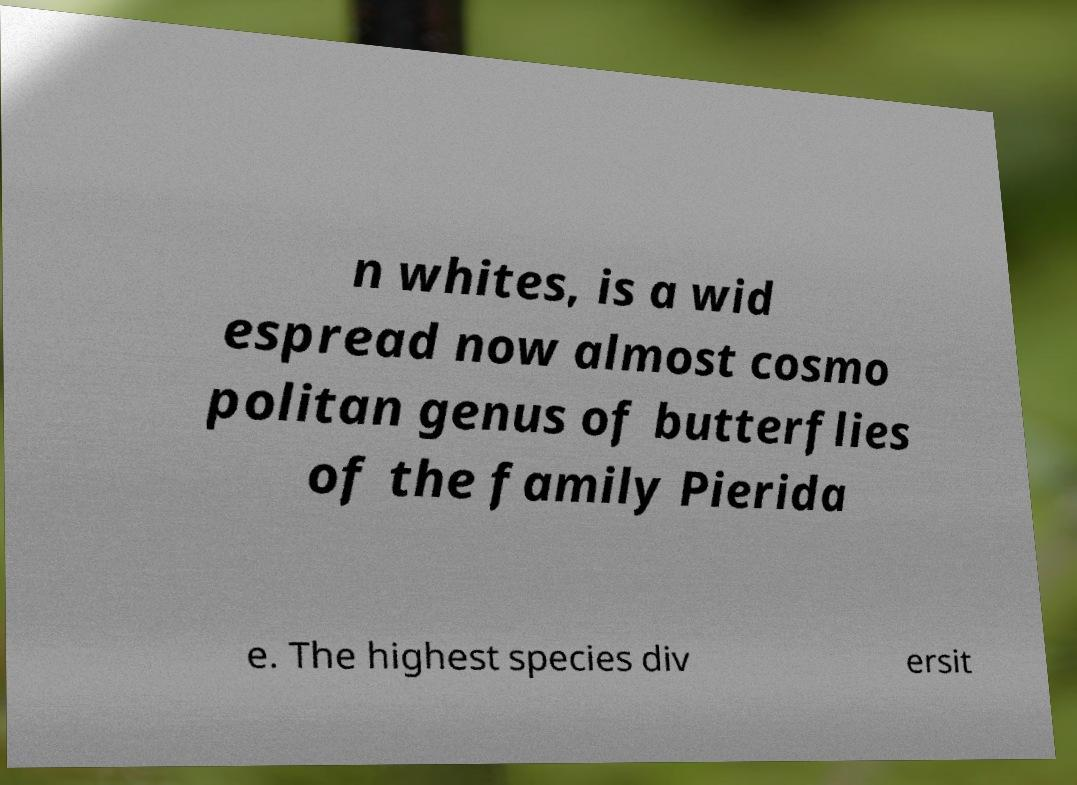Please read and relay the text visible in this image. What does it say? n whites, is a wid espread now almost cosmo politan genus of butterflies of the family Pierida e. The highest species div ersit 